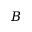<formula> <loc_0><loc_0><loc_500><loc_500>B</formula> 